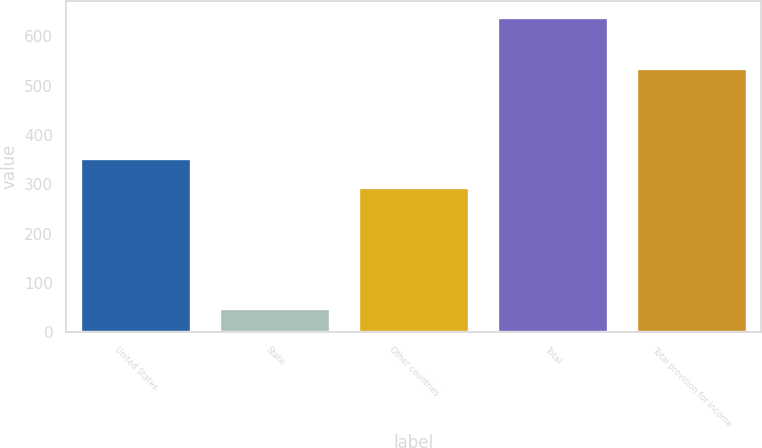Convert chart to OTSL. <chart><loc_0><loc_0><loc_500><loc_500><bar_chart><fcel>United States<fcel>State<fcel>Other countries<fcel>Total<fcel>Total provision for income<nl><fcel>353.3<fcel>49.5<fcel>294.3<fcel>639.5<fcel>536.5<nl></chart> 